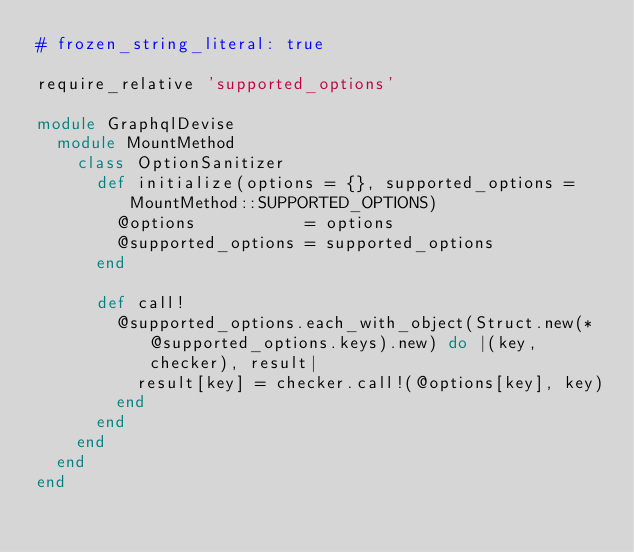Convert code to text. <code><loc_0><loc_0><loc_500><loc_500><_Ruby_># frozen_string_literal: true

require_relative 'supported_options'

module GraphqlDevise
  module MountMethod
    class OptionSanitizer
      def initialize(options = {}, supported_options = MountMethod::SUPPORTED_OPTIONS)
        @options           = options
        @supported_options = supported_options
      end

      def call!
        @supported_options.each_with_object(Struct.new(*@supported_options.keys).new) do |(key, checker), result|
          result[key] = checker.call!(@options[key], key)
        end
      end
    end
  end
end
</code> 